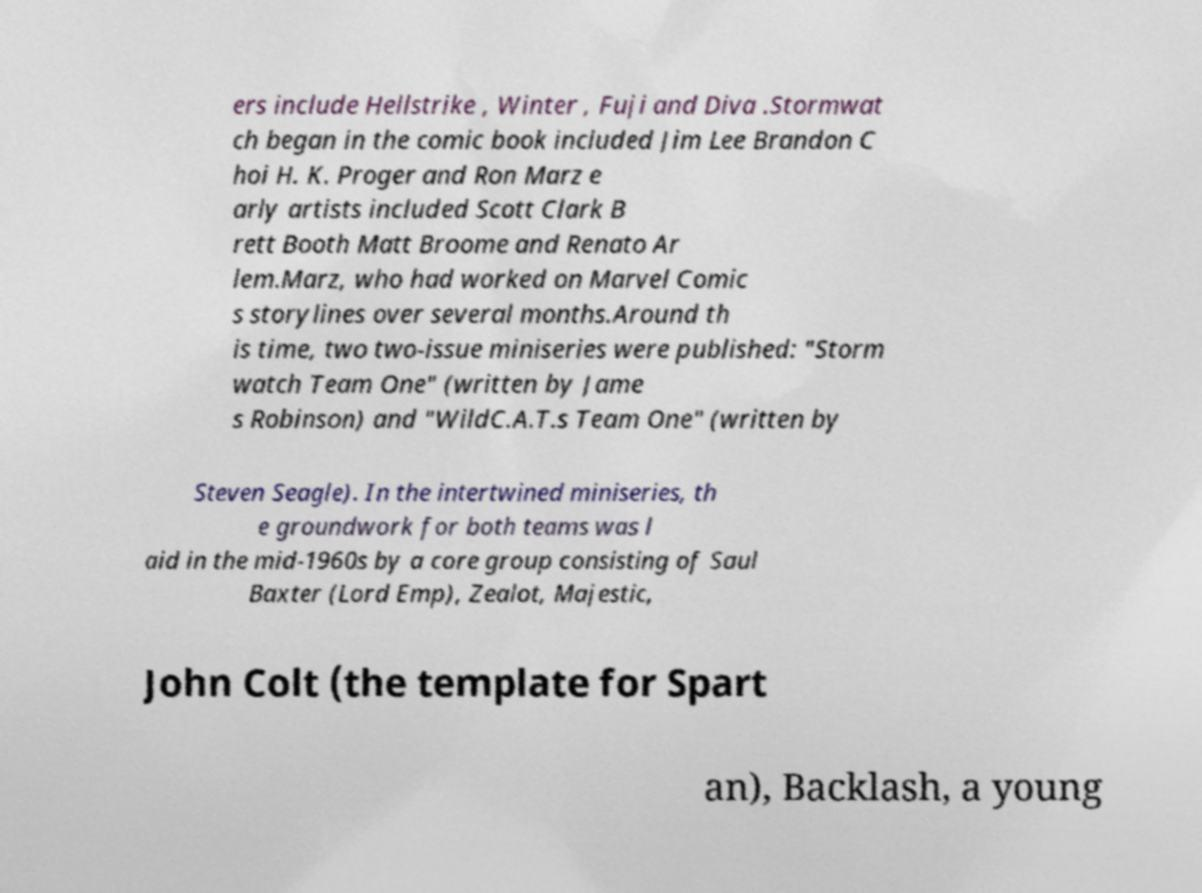Could you extract and type out the text from this image? ers include Hellstrike , Winter , Fuji and Diva .Stormwat ch began in the comic book included Jim Lee Brandon C hoi H. K. Proger and Ron Marz e arly artists included Scott Clark B rett Booth Matt Broome and Renato Ar lem.Marz, who had worked on Marvel Comic s storylines over several months.Around th is time, two two-issue miniseries were published: "Storm watch Team One" (written by Jame s Robinson) and "WildC.A.T.s Team One" (written by Steven Seagle). In the intertwined miniseries, th e groundwork for both teams was l aid in the mid-1960s by a core group consisting of Saul Baxter (Lord Emp), Zealot, Majestic, John Colt (the template for Spart an), Backlash, a young 